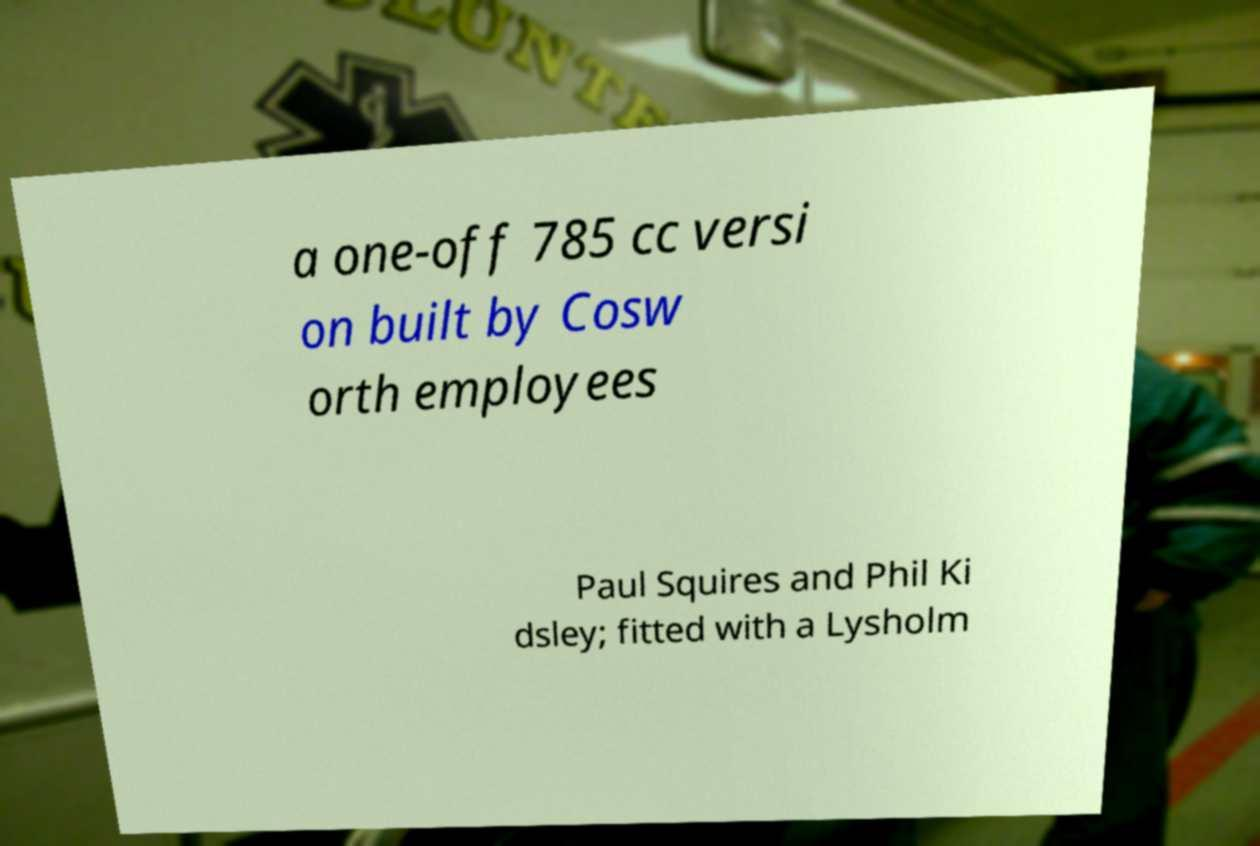There's text embedded in this image that I need extracted. Can you transcribe it verbatim? a one-off 785 cc versi on built by Cosw orth employees Paul Squires and Phil Ki dsley; fitted with a Lysholm 